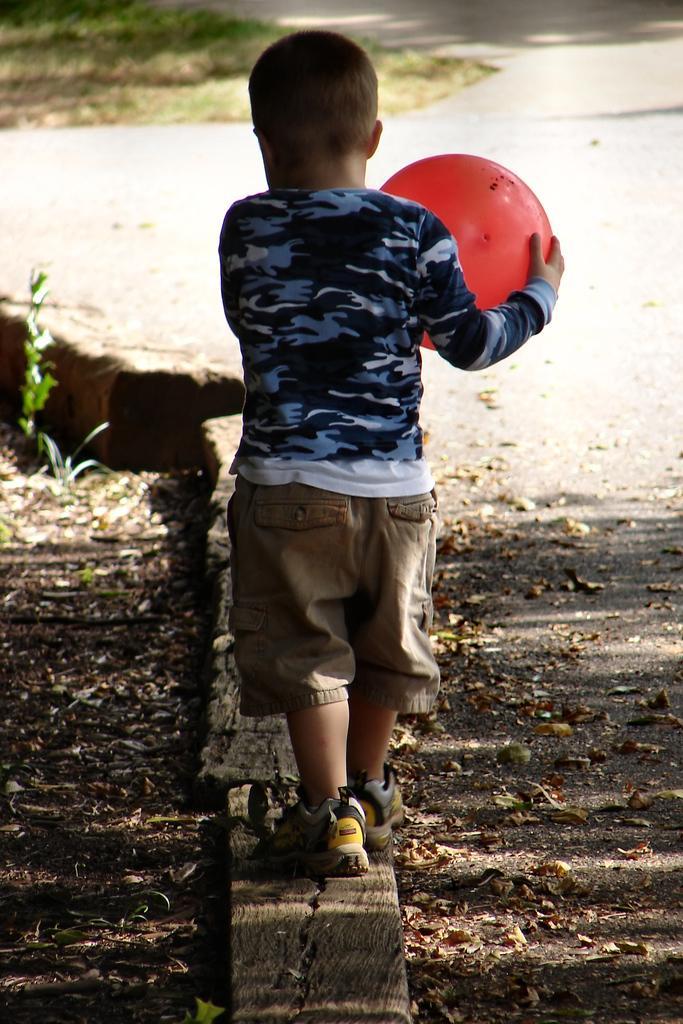Can you describe this image briefly? In this image there is a boy, he is holding a ball, there is road, there are dried leaves on the road, there is soil towards the left of the image, there are plants towards the left of the image, there is grass towards the top of the image. 